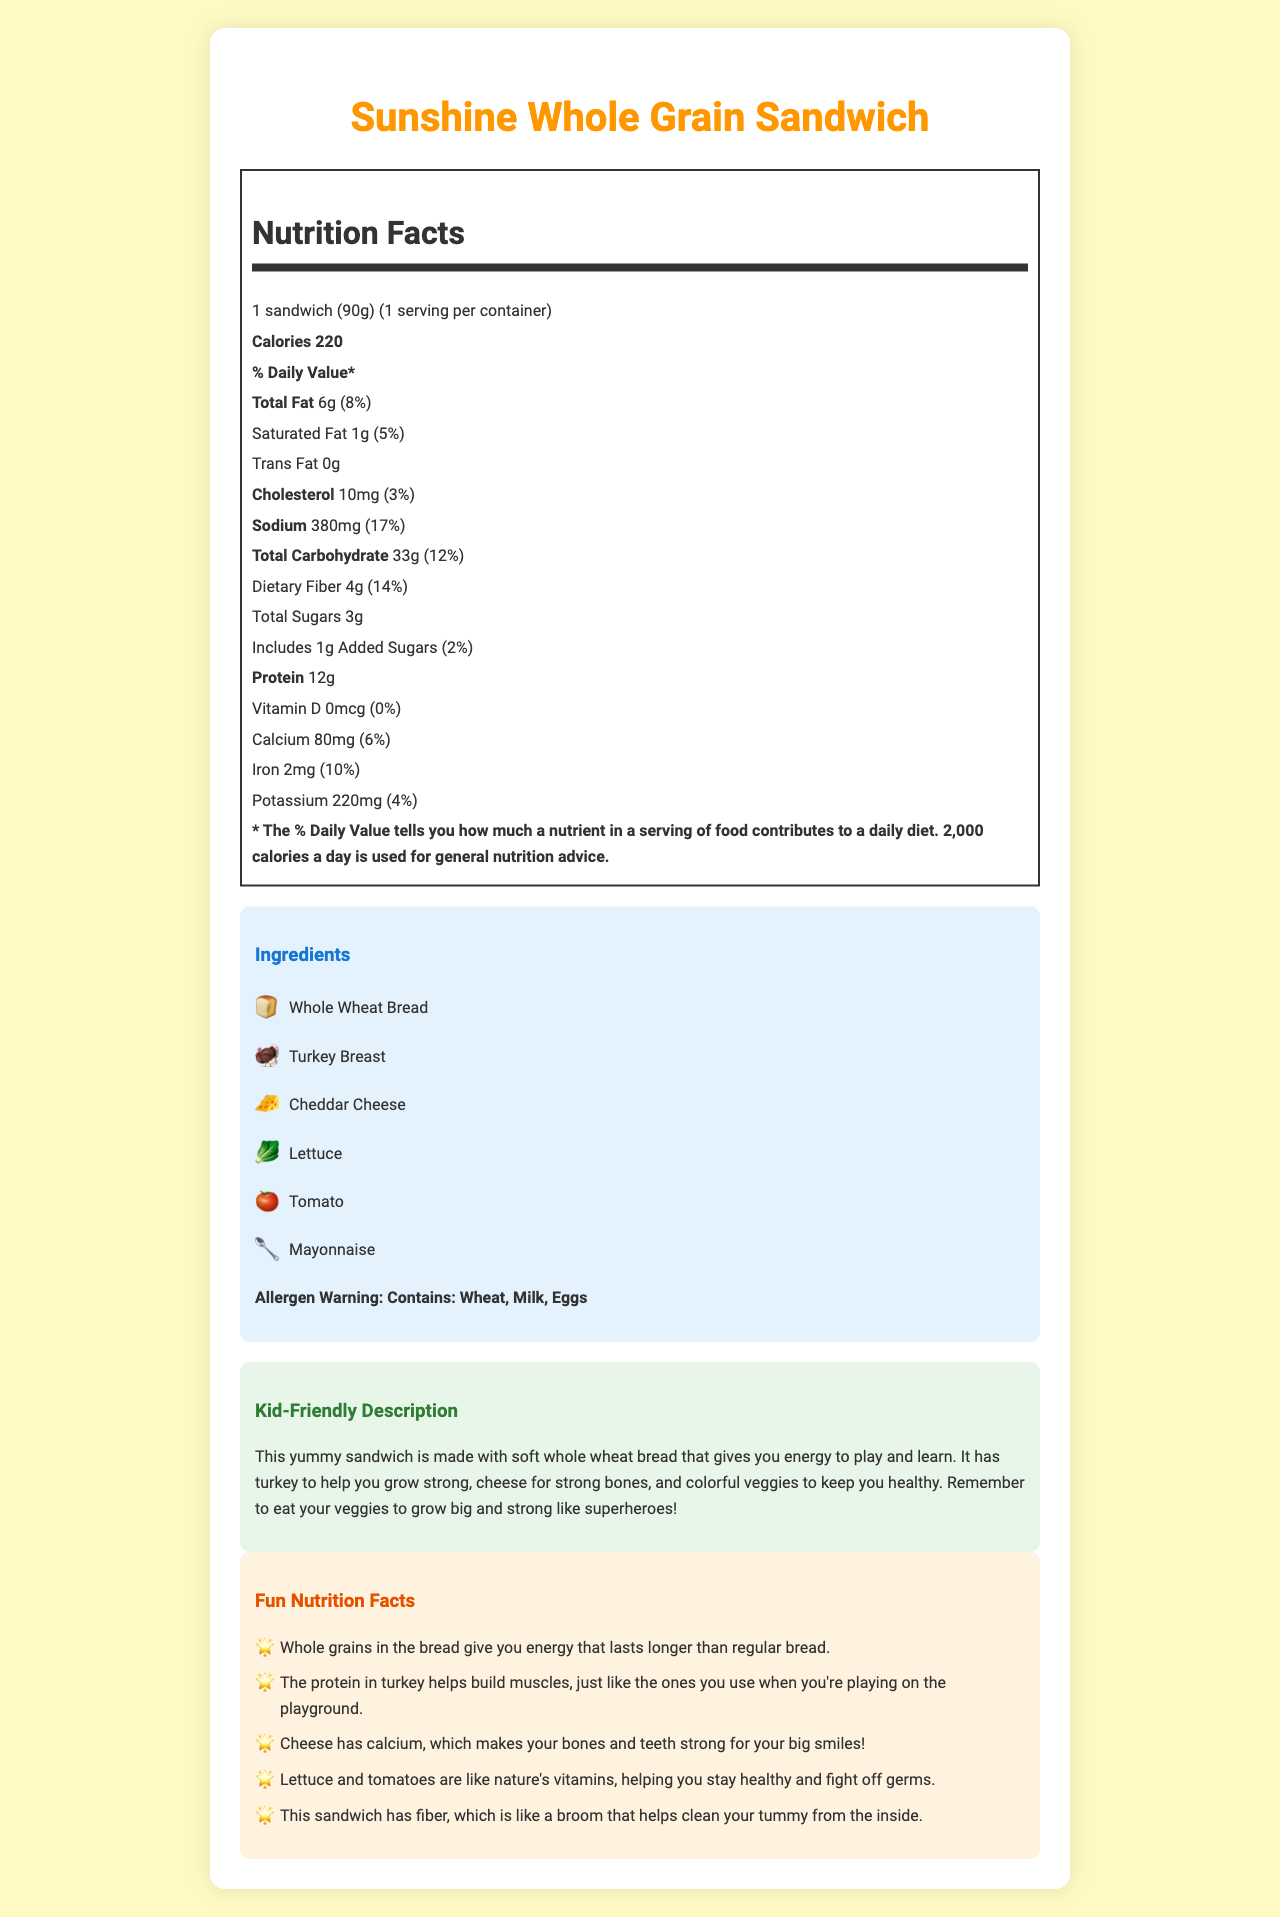what is the serving size of the Sunshine Whole Grain Sandwich? The serving size is specified at the top of the Nutrition Facts section as "1 sandwich (90g)".
Answer: 1 sandwich (90g) how many calories are in one serving of the sandwich? The calories per serving are mentioned at the top of the Nutrition Facts section as "Calories 220".
Answer: 220 how much protein does the sandwich contain? Protein content is listed as "Protein 12g" in the Nutrition Facts section.
Answer: 12g what is the allergen warning for the sandwich? The allergen warning is stated in bold at the end of the ingredients section.
Answer: Contains: Wheat, Milk, Eggs how much calcium is in the sandwich, and what percentage of the daily value does it provide? Calcium content is given in the Nutrition Facts section as "Calcium 80mg (6%)".
Answer: 80mg, 6% which ingredient is represented by the emoji 🥬? A. Tomato B. Lettuce C. Mayonnaise The emoji 🥬 is used next to "Lettuce" in the ingredients list.
Answer: B how much dietary fiber does the sandwich contain? The dietary fiber amount is listed as "Dietary Fiber 4g" in the Nutrition Facts section.
Answer: 4g what is the total carbohydrate content in the sandwich? Total carbohydrate content is stated as "Total Carbohydrate 33g" in the Nutrition Facts section.
Answer: 33g which of the following nutrients does the sandwich not have any of? A. Potassium B. Vitamin D C. Iron D. Sodium Vitamin D is listed with "0mcg" in the Nutrition Facts section, indicating the sandwich has none.
Answer: B is the sandwich high in total fat based on the % Daily Value? The total fat is 8% of the daily value, which suggests it is not high.
Answer: No summarize the main idea of the document, including key nutritional information and kid-friendly aspects. The document provides a detailed breakdown of the nutritional content, ingredients, allergen warnings, and includes a kid-friendly description and fun nutrition insights to make healthy eating appealing to children.
Answer: The Sunshine Whole Grain Sandwich is a healthy option containing 220 calories per serving. It includes 6g of total fat, 12g of protein, 33g of carbohydrates, and 4g of dietary fiber. The sandwich has essential nutrients like calcium and iron and is made with whole wheat bread, turkey breast, cheddar cheese, lettuce, tomato, and mayonnaise. It also provides fun nutrition facts to help kids understand the benefits of the ingredients. what is the total amount of sugars in the sandwich? The total sugars are listed as "Total Sugars 3g" in the Nutrition Facts section.
Answer: 3g how much sodium does the sandwich contain, and what percentage of the daily value does this represent? Sodium content is given as "Sodium 380mg (17%)" in the Nutrition Facts section.
Answer: 380mg, 17% what is one benefit of eating whole grains mentioned in the fun nutrition facts? The first fun nutrition fact states one benefit of whole grains is providing longer-lasting energy.
Answer: Whole grains in the bread give you energy that lasts longer than regular bread. how many servings are there per container? The servings per container are specified at the top of the Nutrition Facts section as "1 serving per container".
Answer: 1 what is one of the teaching points for discussing the sandwich with children? One of the teaching points is to encourage kids to recognize the various food groups in the sandwich, as stated in the Teaching Points section.
Answer: Encourage children to identify the different food groups represented in the sandwich. does the sandwich contain any trans fat? Trans fat is listed as "0g" in the Nutrition Facts section, indicating there is none.
Answer: No how much iron does the sandwich contain? Iron content is listed as "Iron 2mg (10%)" in the Nutrition Facts section.
Answer: 2mg what is the product name of the sandwich described in the document? The product name is displayed at the top and in the title as "Sunshine Whole Grain Sandwich".
Answer: Sunshine Whole Grain Sandwich which of the following is not listed as an ingredient in the sandwich? A. Turkey Breast B. Ham C. Cheddar Cheese D. Whole Wheat Bread Ham is not listed among the ingredients; the other options are included.
Answer: B 